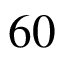<formula> <loc_0><loc_0><loc_500><loc_500>6 0</formula> 